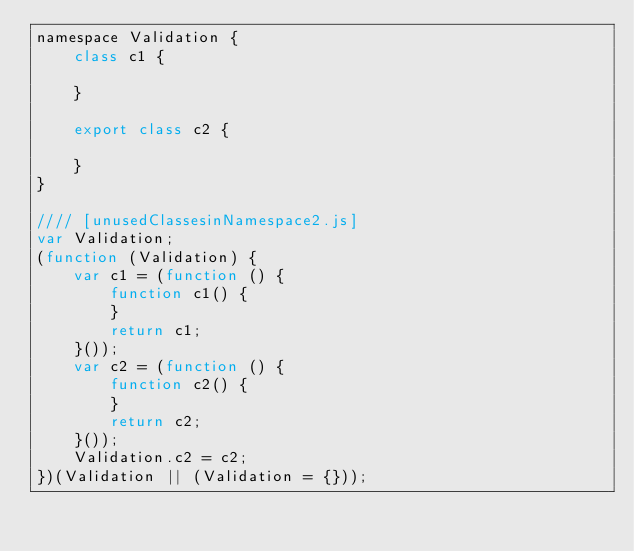<code> <loc_0><loc_0><loc_500><loc_500><_JavaScript_>namespace Validation {
    class c1 {

    }

    export class c2 {

    }
}

//// [unusedClassesinNamespace2.js]
var Validation;
(function (Validation) {
    var c1 = (function () {
        function c1() {
        }
        return c1;
    }());
    var c2 = (function () {
        function c2() {
        }
        return c2;
    }());
    Validation.c2 = c2;
})(Validation || (Validation = {}));
</code> 